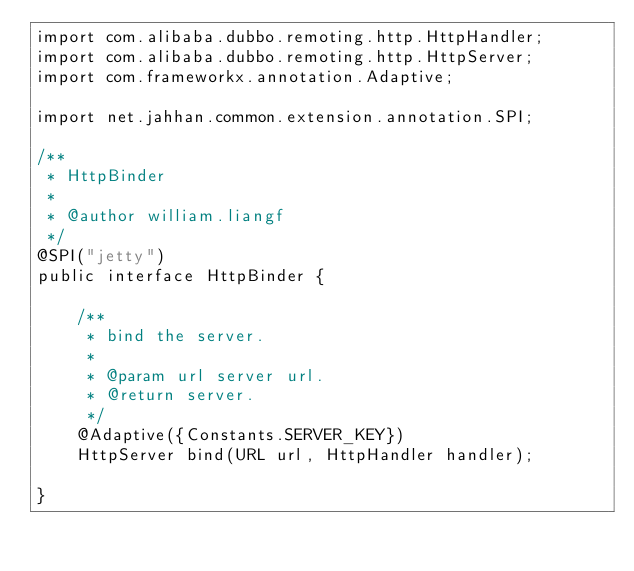<code> <loc_0><loc_0><loc_500><loc_500><_Java_>import com.alibaba.dubbo.remoting.http.HttpHandler;
import com.alibaba.dubbo.remoting.http.HttpServer;
import com.frameworkx.annotation.Adaptive;

import net.jahhan.common.extension.annotation.SPI;

/**
 * HttpBinder
 * 
 * @author william.liangf
 */
@SPI("jetty")
public interface HttpBinder {
    
    /**
     * bind the server.
     * 
     * @param url server url.
     * @return server.
     */
    @Adaptive({Constants.SERVER_KEY})
    HttpServer bind(URL url, HttpHandler handler);
    
}</code> 